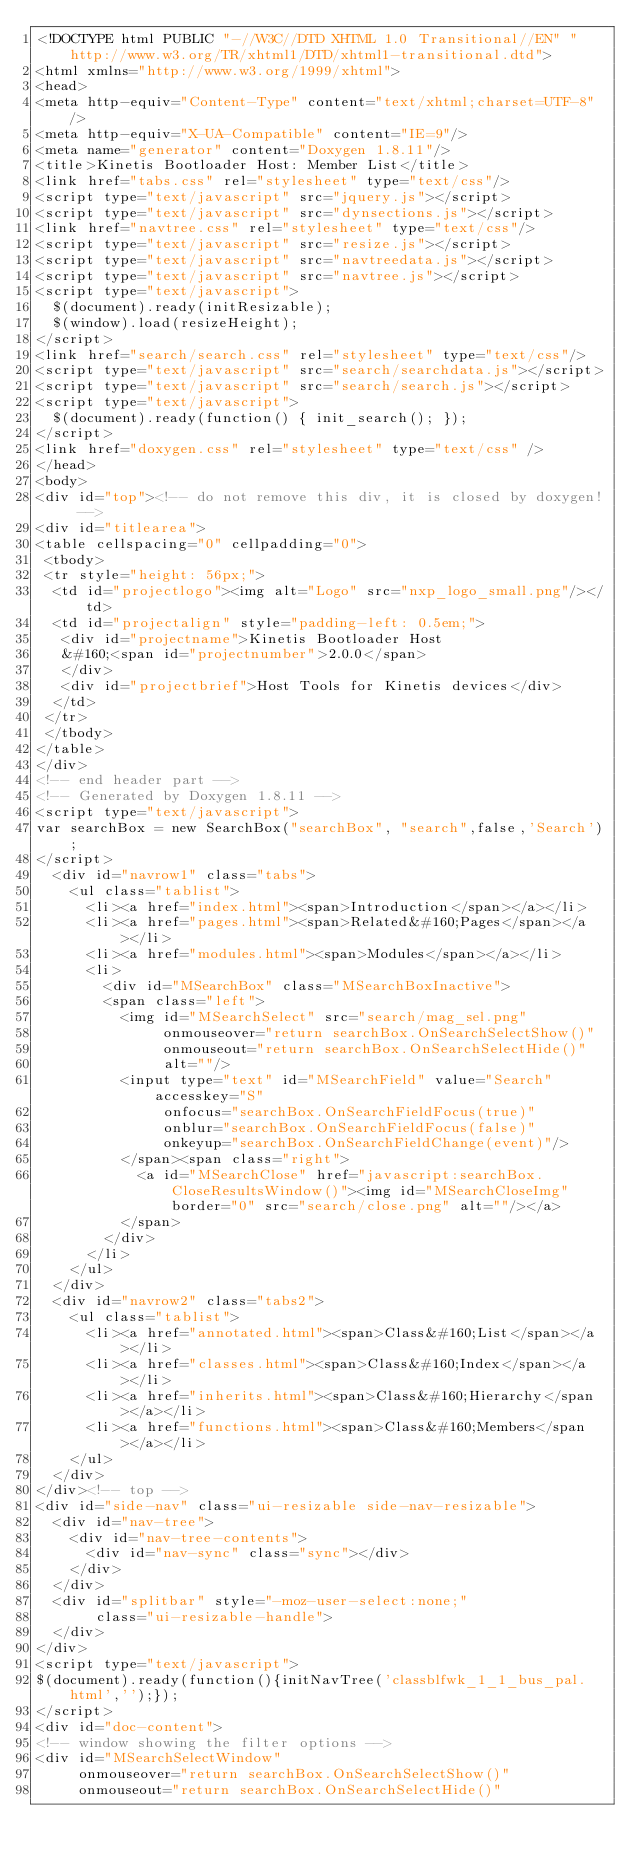Convert code to text. <code><loc_0><loc_0><loc_500><loc_500><_HTML_><!DOCTYPE html PUBLIC "-//W3C//DTD XHTML 1.0 Transitional//EN" "http://www.w3.org/TR/xhtml1/DTD/xhtml1-transitional.dtd">
<html xmlns="http://www.w3.org/1999/xhtml">
<head>
<meta http-equiv="Content-Type" content="text/xhtml;charset=UTF-8"/>
<meta http-equiv="X-UA-Compatible" content="IE=9"/>
<meta name="generator" content="Doxygen 1.8.11"/>
<title>Kinetis Bootloader Host: Member List</title>
<link href="tabs.css" rel="stylesheet" type="text/css"/>
<script type="text/javascript" src="jquery.js"></script>
<script type="text/javascript" src="dynsections.js"></script>
<link href="navtree.css" rel="stylesheet" type="text/css"/>
<script type="text/javascript" src="resize.js"></script>
<script type="text/javascript" src="navtreedata.js"></script>
<script type="text/javascript" src="navtree.js"></script>
<script type="text/javascript">
  $(document).ready(initResizable);
  $(window).load(resizeHeight);
</script>
<link href="search/search.css" rel="stylesheet" type="text/css"/>
<script type="text/javascript" src="search/searchdata.js"></script>
<script type="text/javascript" src="search/search.js"></script>
<script type="text/javascript">
  $(document).ready(function() { init_search(); });
</script>
<link href="doxygen.css" rel="stylesheet" type="text/css" />
</head>
<body>
<div id="top"><!-- do not remove this div, it is closed by doxygen! -->
<div id="titlearea">
<table cellspacing="0" cellpadding="0">
 <tbody>
 <tr style="height: 56px;">
  <td id="projectlogo"><img alt="Logo" src="nxp_logo_small.png"/></td>
  <td id="projectalign" style="padding-left: 0.5em;">
   <div id="projectname">Kinetis Bootloader Host
   &#160;<span id="projectnumber">2.0.0</span>
   </div>
   <div id="projectbrief">Host Tools for Kinetis devices</div>
  </td>
 </tr>
 </tbody>
</table>
</div>
<!-- end header part -->
<!-- Generated by Doxygen 1.8.11 -->
<script type="text/javascript">
var searchBox = new SearchBox("searchBox", "search",false,'Search');
</script>
  <div id="navrow1" class="tabs">
    <ul class="tablist">
      <li><a href="index.html"><span>Introduction</span></a></li>
      <li><a href="pages.html"><span>Related&#160;Pages</span></a></li>
      <li><a href="modules.html"><span>Modules</span></a></li>
      <li>
        <div id="MSearchBox" class="MSearchBoxInactive">
        <span class="left">
          <img id="MSearchSelect" src="search/mag_sel.png"
               onmouseover="return searchBox.OnSearchSelectShow()"
               onmouseout="return searchBox.OnSearchSelectHide()"
               alt=""/>
          <input type="text" id="MSearchField" value="Search" accesskey="S"
               onfocus="searchBox.OnSearchFieldFocus(true)" 
               onblur="searchBox.OnSearchFieldFocus(false)" 
               onkeyup="searchBox.OnSearchFieldChange(event)"/>
          </span><span class="right">
            <a id="MSearchClose" href="javascript:searchBox.CloseResultsWindow()"><img id="MSearchCloseImg" border="0" src="search/close.png" alt=""/></a>
          </span>
        </div>
      </li>
    </ul>
  </div>
  <div id="navrow2" class="tabs2">
    <ul class="tablist">
      <li><a href="annotated.html"><span>Class&#160;List</span></a></li>
      <li><a href="classes.html"><span>Class&#160;Index</span></a></li>
      <li><a href="inherits.html"><span>Class&#160;Hierarchy</span></a></li>
      <li><a href="functions.html"><span>Class&#160;Members</span></a></li>
    </ul>
  </div>
</div><!-- top -->
<div id="side-nav" class="ui-resizable side-nav-resizable">
  <div id="nav-tree">
    <div id="nav-tree-contents">
      <div id="nav-sync" class="sync"></div>
    </div>
  </div>
  <div id="splitbar" style="-moz-user-select:none;" 
       class="ui-resizable-handle">
  </div>
</div>
<script type="text/javascript">
$(document).ready(function(){initNavTree('classblfwk_1_1_bus_pal.html','');});
</script>
<div id="doc-content">
<!-- window showing the filter options -->
<div id="MSearchSelectWindow"
     onmouseover="return searchBox.OnSearchSelectShow()"
     onmouseout="return searchBox.OnSearchSelectHide()"</code> 